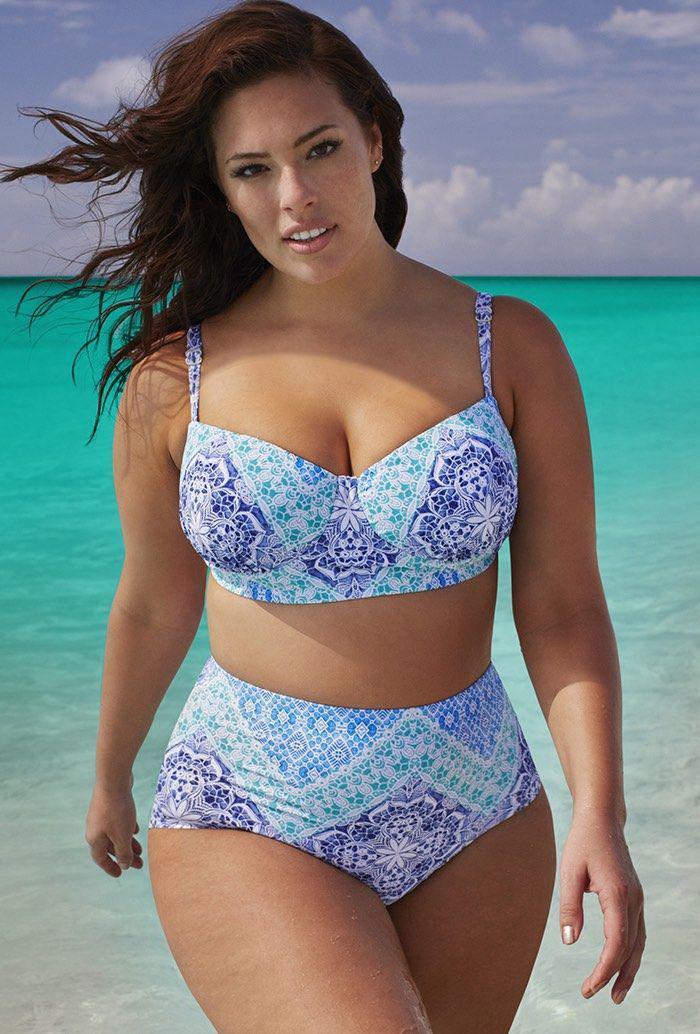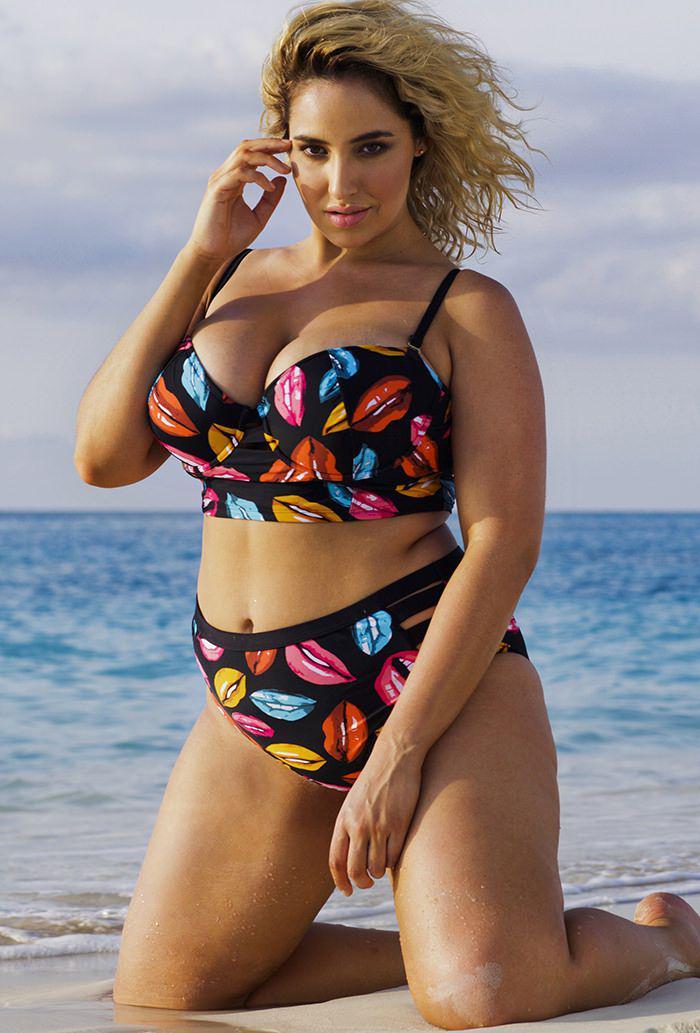The first image is the image on the left, the second image is the image on the right. Analyze the images presented: Is the assertion "the same model is wearing a bright green bikini" valid? Answer yes or no. No. The first image is the image on the left, the second image is the image on the right. Examine the images to the left and right. Is the description "A woman is wearing a solid black two piece bathing suit." accurate? Answer yes or no. No. 